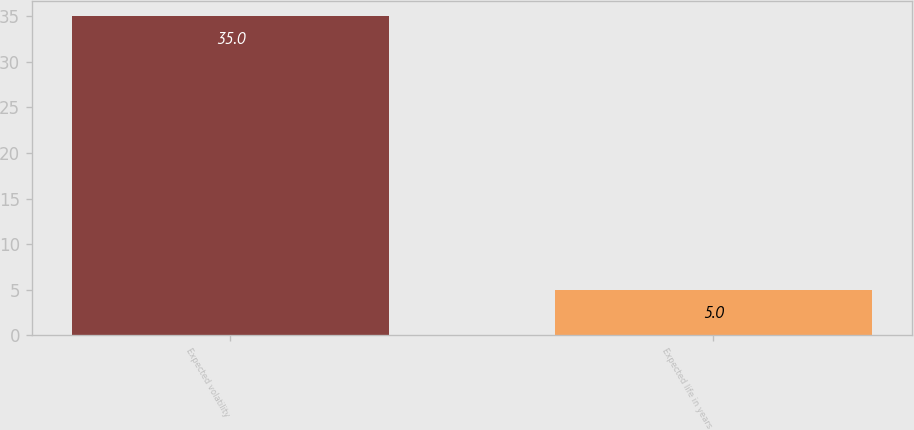Convert chart to OTSL. <chart><loc_0><loc_0><loc_500><loc_500><bar_chart><fcel>Expected volatility<fcel>Expected life in years<nl><fcel>35<fcel>5<nl></chart> 